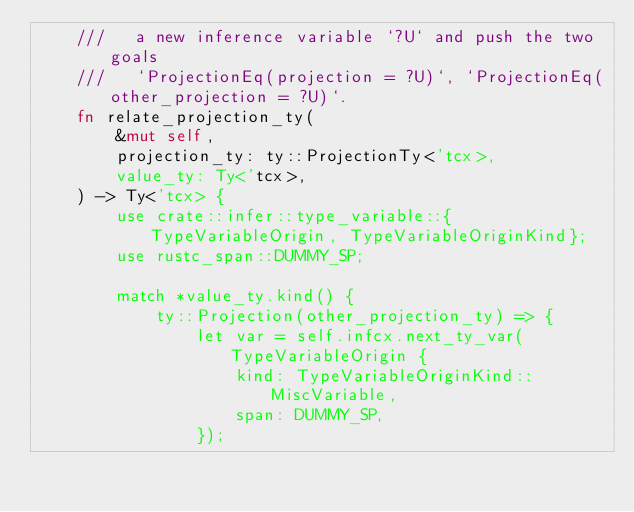Convert code to text. <code><loc_0><loc_0><loc_500><loc_500><_Rust_>    ///   a new inference variable `?U` and push the two goals
    ///   `ProjectionEq(projection = ?U)`, `ProjectionEq(other_projection = ?U)`.
    fn relate_projection_ty(
        &mut self,
        projection_ty: ty::ProjectionTy<'tcx>,
        value_ty: Ty<'tcx>,
    ) -> Ty<'tcx> {
        use crate::infer::type_variable::{TypeVariableOrigin, TypeVariableOriginKind};
        use rustc_span::DUMMY_SP;

        match *value_ty.kind() {
            ty::Projection(other_projection_ty) => {
                let var = self.infcx.next_ty_var(TypeVariableOrigin {
                    kind: TypeVariableOriginKind::MiscVariable,
                    span: DUMMY_SP,
                });</code> 